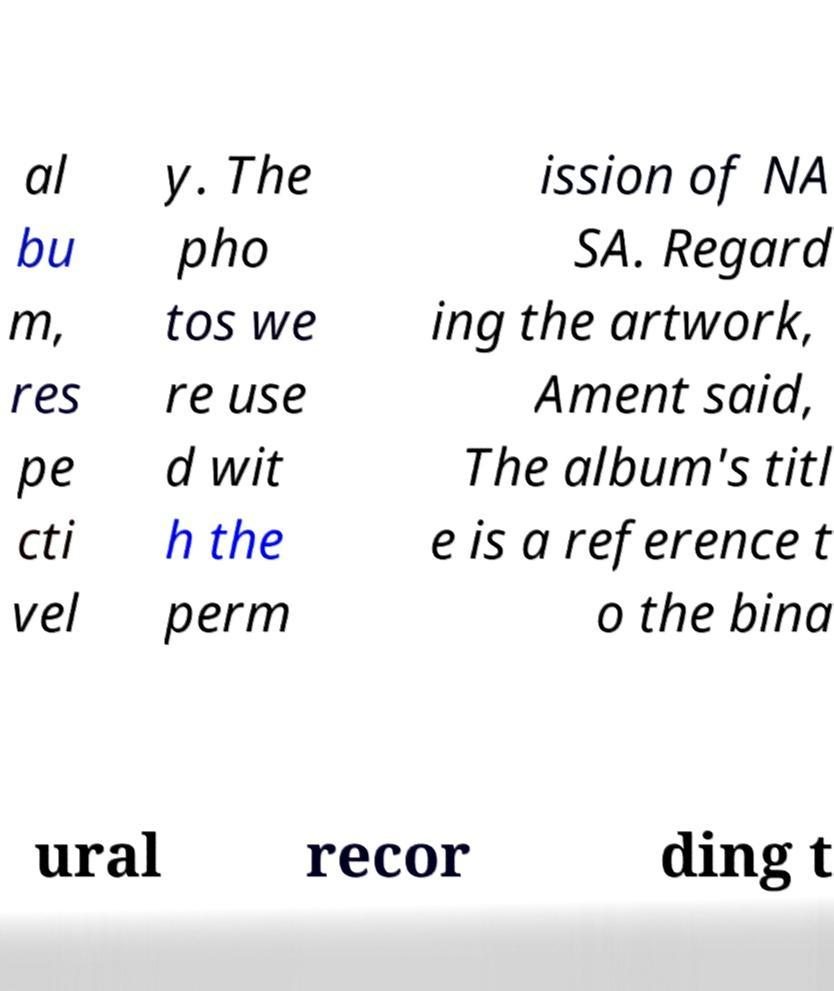Can you read and provide the text displayed in the image?This photo seems to have some interesting text. Can you extract and type it out for me? al bu m, res pe cti vel y. The pho tos we re use d wit h the perm ission of NA SA. Regard ing the artwork, Ament said, The album's titl e is a reference t o the bina ural recor ding t 